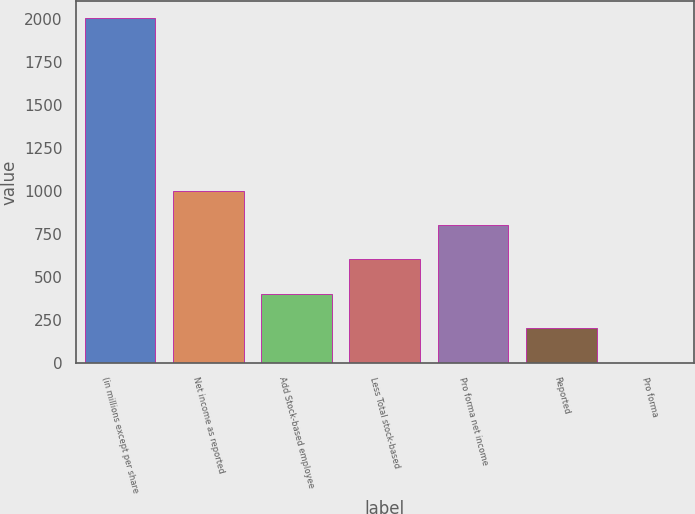Convert chart to OTSL. <chart><loc_0><loc_0><loc_500><loc_500><bar_chart><fcel>(in millions except per share<fcel>Net income as reported<fcel>Add Stock-based employee<fcel>Less Total stock-based<fcel>Pro forma net income<fcel>Reported<fcel>Pro forma<nl><fcel>2003<fcel>1001.75<fcel>401<fcel>601.25<fcel>801.5<fcel>200.75<fcel>0.5<nl></chart> 